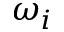<formula> <loc_0><loc_0><loc_500><loc_500>\omega _ { i }</formula> 